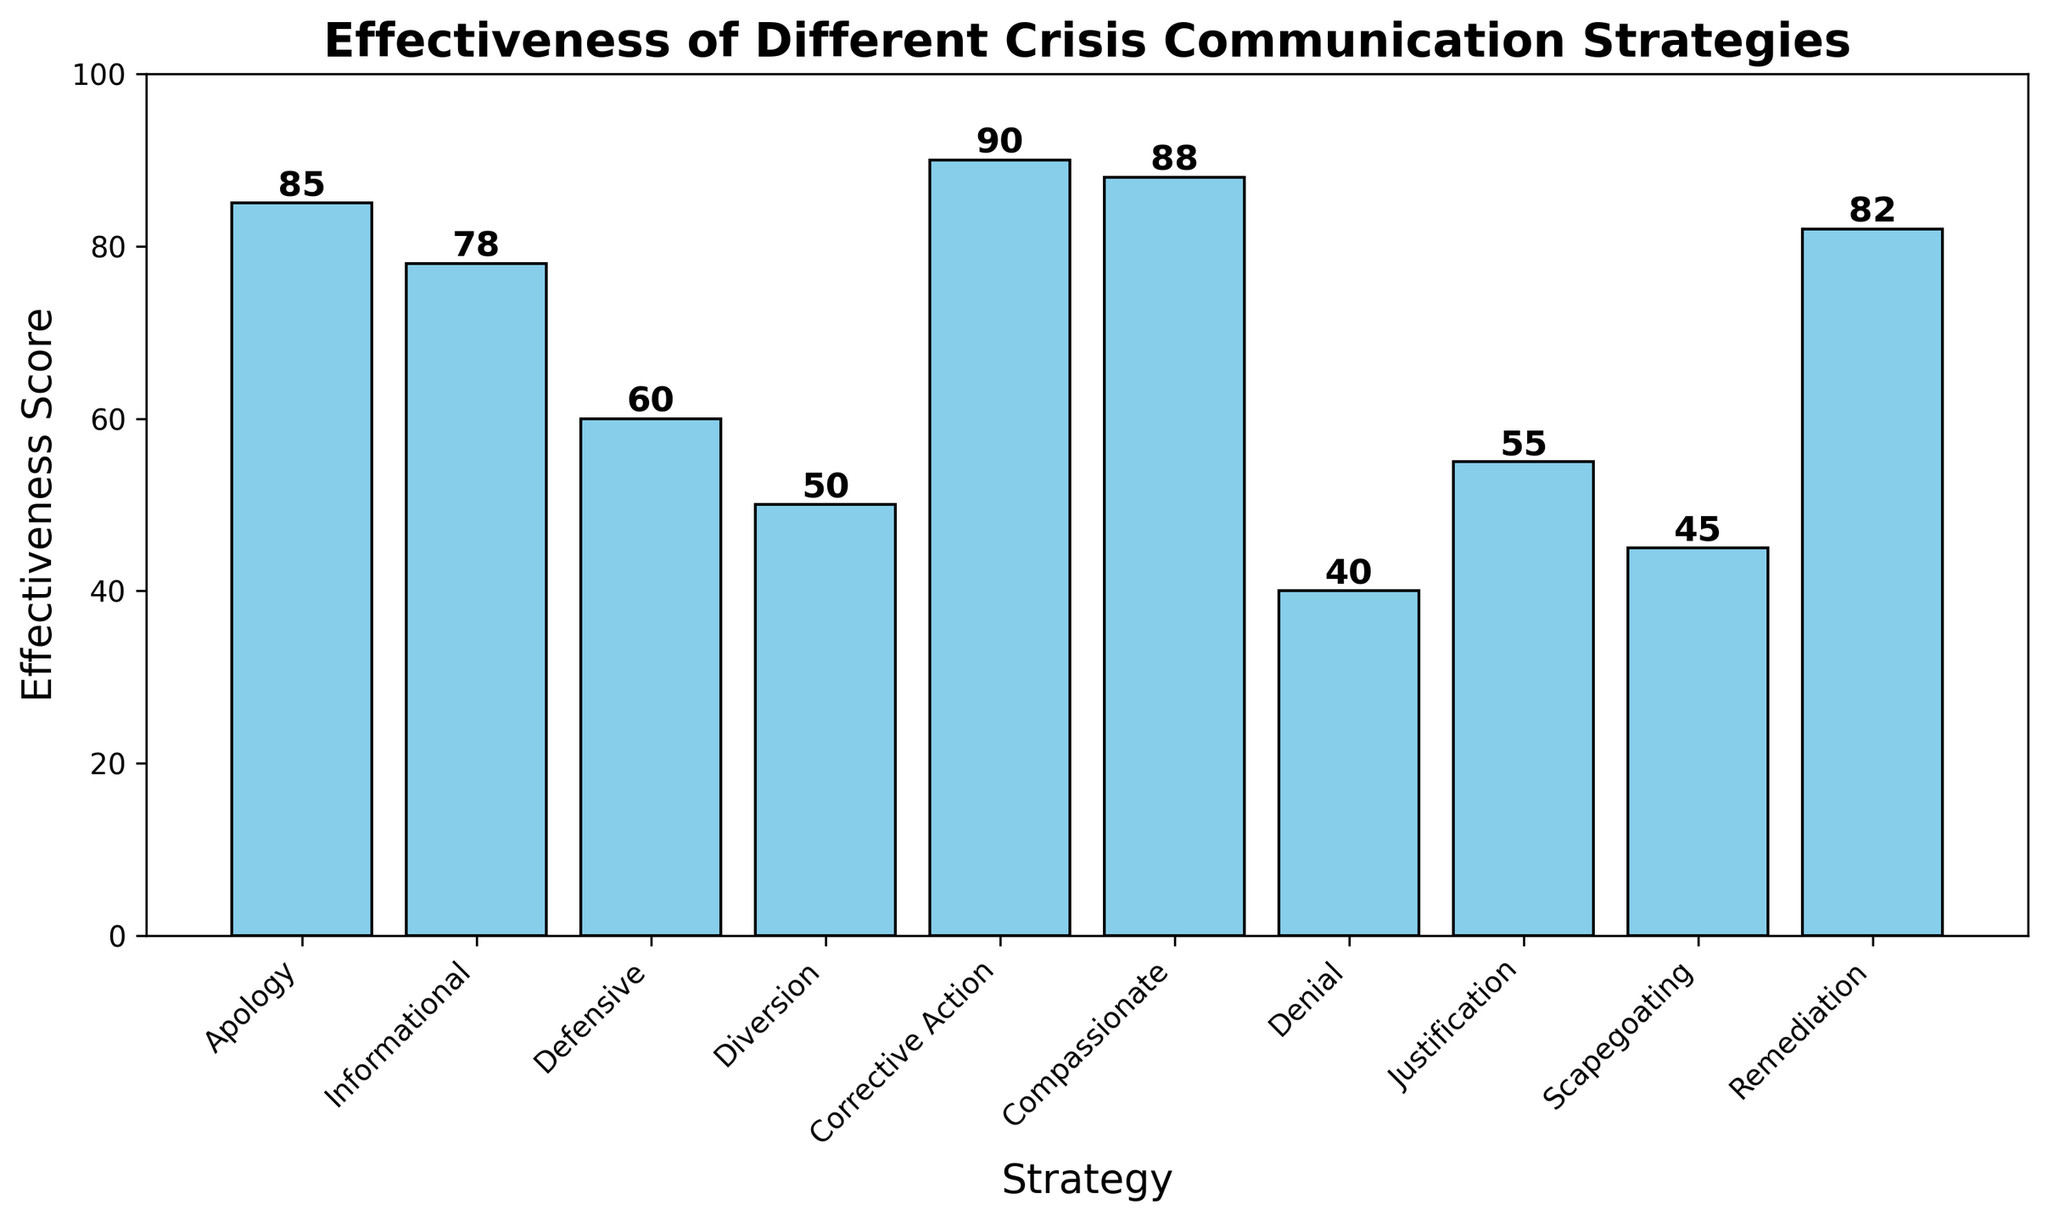What's the most effective crisis communication strategy based on the survey data? The most effective strategy will have the highest effectiveness score. According to the bar chart, Corrective Action has the highest score of 90.
Answer: Corrective Action Which two strategies are the least effective based on the effectiveness scores? The least effective strategies are the ones with the lowest effectiveness scores. According to the chart, Denial (40) and Scapegoating (45) have the lowest scores.
Answer: Denial and Scapegoating How much more effective is the Compassionate strategy compared to the Defensive strategy? Subtract the effectiveness score of the Defensive strategy from the effectiveness score of the Compassionate strategy. Compassionate (88) - Defensive (60) = 28
Answer: 28 What is the combined effectiveness score of Apology, Informational, and Remediation strategies? Sum the effectiveness scores of Apology, Informational, and Remediation strategies. Apology (85) + Informational (78) + Remediation (82) = 245
Answer: 245 Which strategy has a higher effectiveness score, Diversion or Justification? Compare the effectiveness scores of Diversion and Justification. Diversion has a score of 50 and Justification has a score of 55. 55 is higher than 50.
Answer: Justification Approximately how much taller is the bar for Corrective Action compared to Denial? The height difference between the bars can be calculated by subtracting the lower effectiveness score from the higher one. Corrective Action (90) - Denial (40) = 50
Answer: 50 What is the average effectiveness score of all the strategies? Add all the effectiveness scores together and divide by the number of strategies. (85+78+60+50+90+88+40+55+45+82)/10 = 67.3
Answer: 67.3 Which strategies have effectiveness scores between 50 and 80? Identify the strategies whose effectiveness scores fall within this range. Informational (78), Defensive (60), Justification (55), and Diversion (50) fall between 50 and 80.
Answer: Informational, Defensive, Justification, and Diversion Is the bar corresponding to Apology taller or shorter than the bar for Remediation? Compare the heights of the bars corresponding to Apology and Remediation. Apology has a score of 85 and Remediation has a score of 82, so Apology is taller.
Answer: Apology 